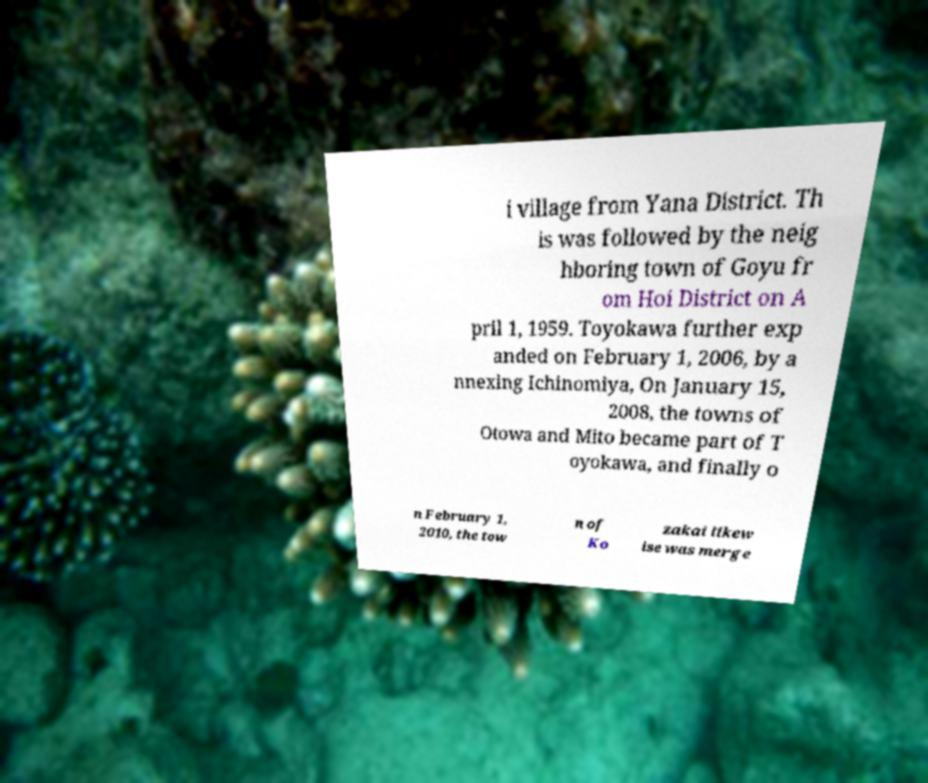Please identify and transcribe the text found in this image. i village from Yana District. Th is was followed by the neig hboring town of Goyu fr om Hoi District on A pril 1, 1959. Toyokawa further exp anded on February 1, 2006, by a nnexing Ichinomiya, On January 15, 2008, the towns of Otowa and Mito became part of T oyokawa, and finally o n February 1, 2010, the tow n of Ko zakai likew ise was merge 